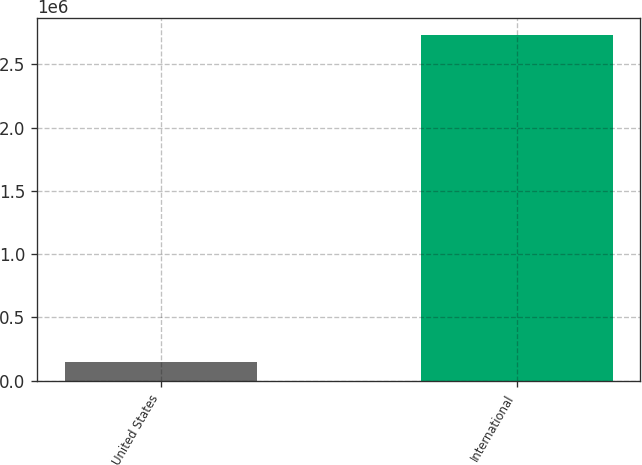Convert chart. <chart><loc_0><loc_0><loc_500><loc_500><bar_chart><fcel>United States<fcel>International<nl><fcel>148773<fcel>2.73038e+06<nl></chart> 